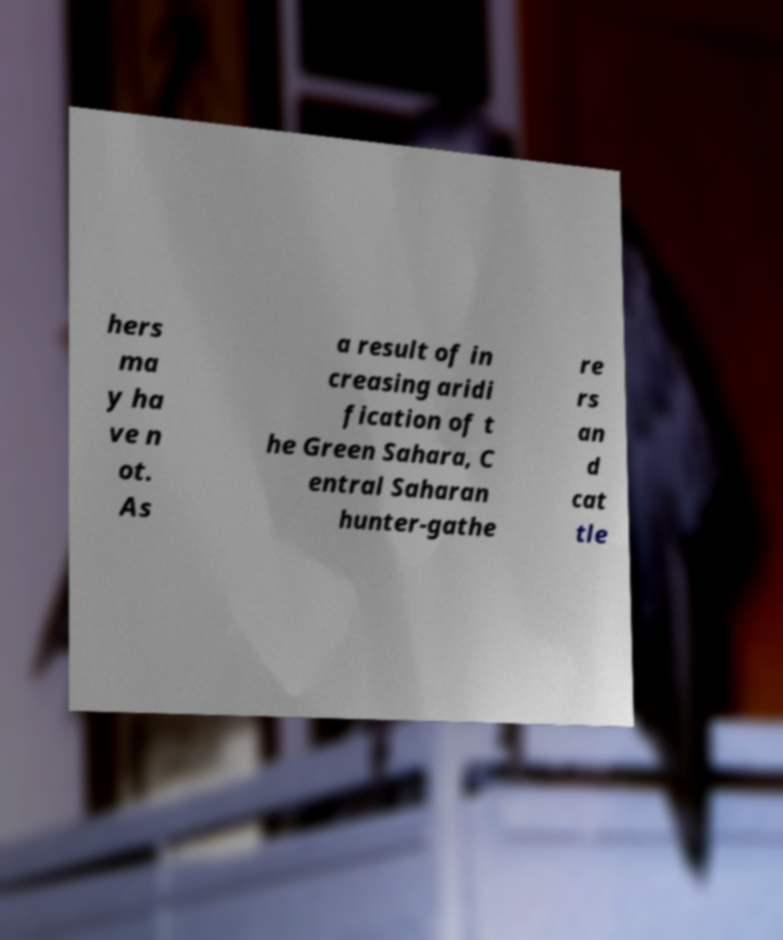What messages or text are displayed in this image? I need them in a readable, typed format. hers ma y ha ve n ot. As a result of in creasing aridi fication of t he Green Sahara, C entral Saharan hunter-gathe re rs an d cat tle 